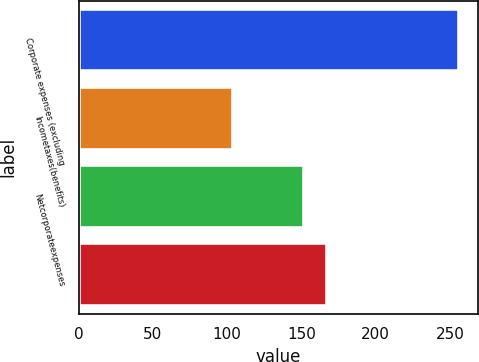<chart> <loc_0><loc_0><loc_500><loc_500><bar_chart><fcel>Corporate expenses (excluding<fcel>Incometaxes(benefits)<fcel>Netcorporateexpenses<fcel>Unnamed: 3<nl><fcel>256<fcel>104<fcel>152<fcel>167.2<nl></chart> 